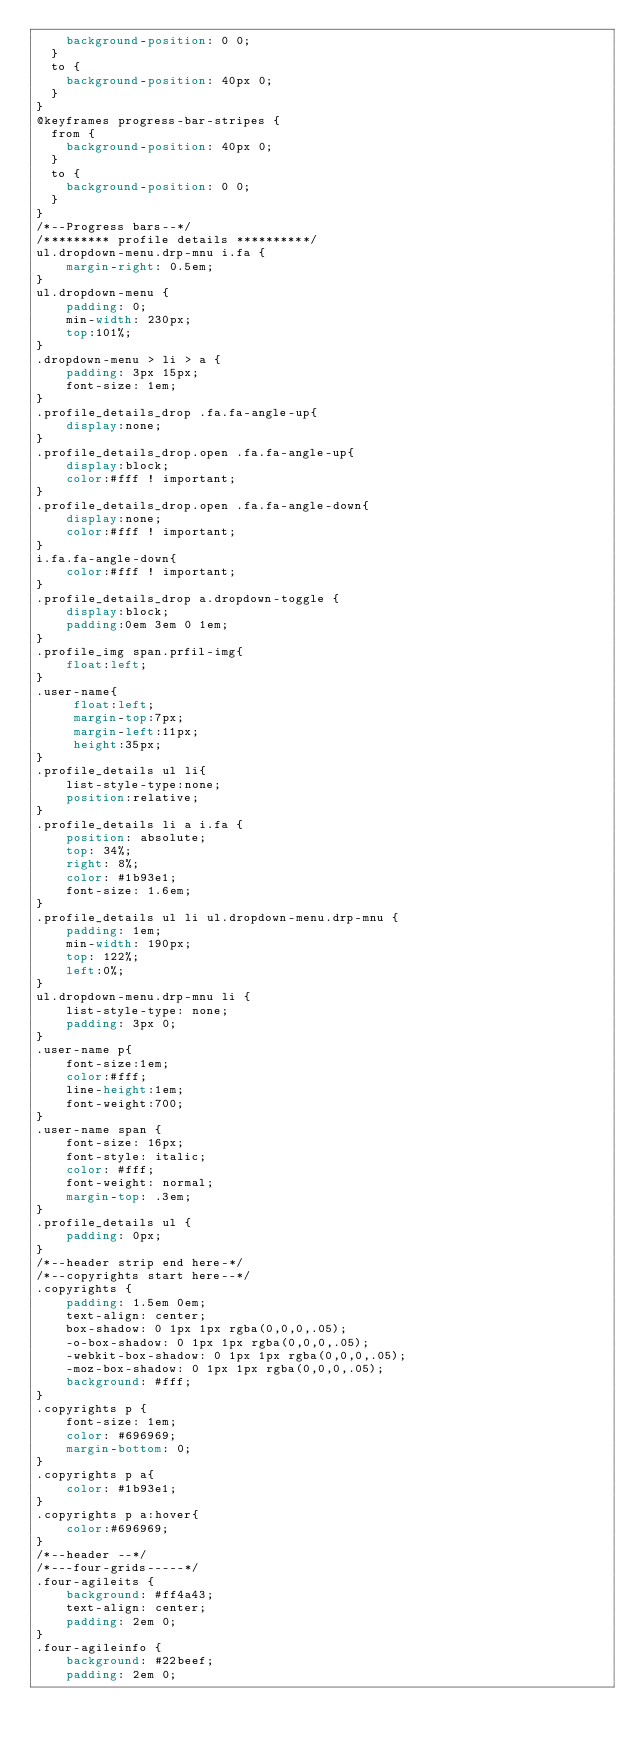<code> <loc_0><loc_0><loc_500><loc_500><_CSS_>    background-position: 0 0;
  }
  to {
    background-position: 40px 0;
  }
}
@keyframes progress-bar-stripes {
  from {
    background-position: 40px 0;
  }
  to {
    background-position: 0 0;
  }
}
/*--Progress bars--*/
/********* profile details **********/
ul.dropdown-menu.drp-mnu i.fa {
    margin-right: 0.5em;
}
ul.dropdown-menu {
    padding: 0;
    min-width: 230px;
    top:101%;
}
.dropdown-menu > li > a {
    padding: 3px 15px;
	font-size: 1em;
}
.profile_details_drop .fa.fa-angle-up{
	display:none;
}
.profile_details_drop.open .fa.fa-angle-up{
    display:block;
	color:#fff ! important;
}
.profile_details_drop.open .fa.fa-angle-down{
	display:none;
	color:#fff ! important;
}
i.fa.fa-angle-down{
	color:#fff ! important;
}
.profile_details_drop a.dropdown-toggle {
    display:block;
	padding:0em 3em 0 1em;
}
.profile_img span.prfil-img{
	float:left;
}
.user-name{
	 float:left;
	 margin-top:7px;
	 margin-left:11px;
	 height:35px;
}
.profile_details ul li{
	list-style-type:none;
	position:relative;
}
.profile_details li a i.fa {
    position: absolute;
    top: 34%;
    right: 8%;
    color: #1b93e1;
    font-size: 1.6em;
}
.profile_details ul li ul.dropdown-menu.drp-mnu {
    padding: 1em;
    min-width: 190px;
    top: 122%;
    left:0%;
}
ul.dropdown-menu.drp-mnu li {
    list-style-type: none;
    padding: 3px 0;
}
.user-name p{
	font-size:1em;
	color:#fff;
	line-height:1em;
	font-weight:700;
}
.user-name span {
    font-size: 16px;
    font-style: italic;
    color: #fff;
    font-weight: normal;
    margin-top: .3em;
}
.profile_details ul {
    padding: 0px;
}
/*--header strip end here-*/
/*--copyrights start here--*/
.copyrights {
    padding: 1.5em 0em;
    text-align: center;
    box-shadow: 0 1px 1px rgba(0,0,0,.05);
    -o-box-shadow: 0 1px 1px rgba(0,0,0,.05);
    -webkit-box-shadow: 0 1px 1px rgba(0,0,0,.05);
    -moz-box-shadow: 0 1px 1px rgba(0,0,0,.05);
    background: #fff;
}
.copyrights p {
    font-size: 1em;
    color: #696969;
    margin-bottom: 0;
}
.copyrights p a{
    color: #1b93e1;
}
.copyrights p a:hover{
    color:#696969;
}
/*--header --*/
/*---four-grids-----*/ 
.four-agileits {
    background: #ff4a43;
    text-align: center;
    padding: 2em 0;
}
.four-agileinfo {
    background: #22beef;
    padding: 2em 0;</code> 